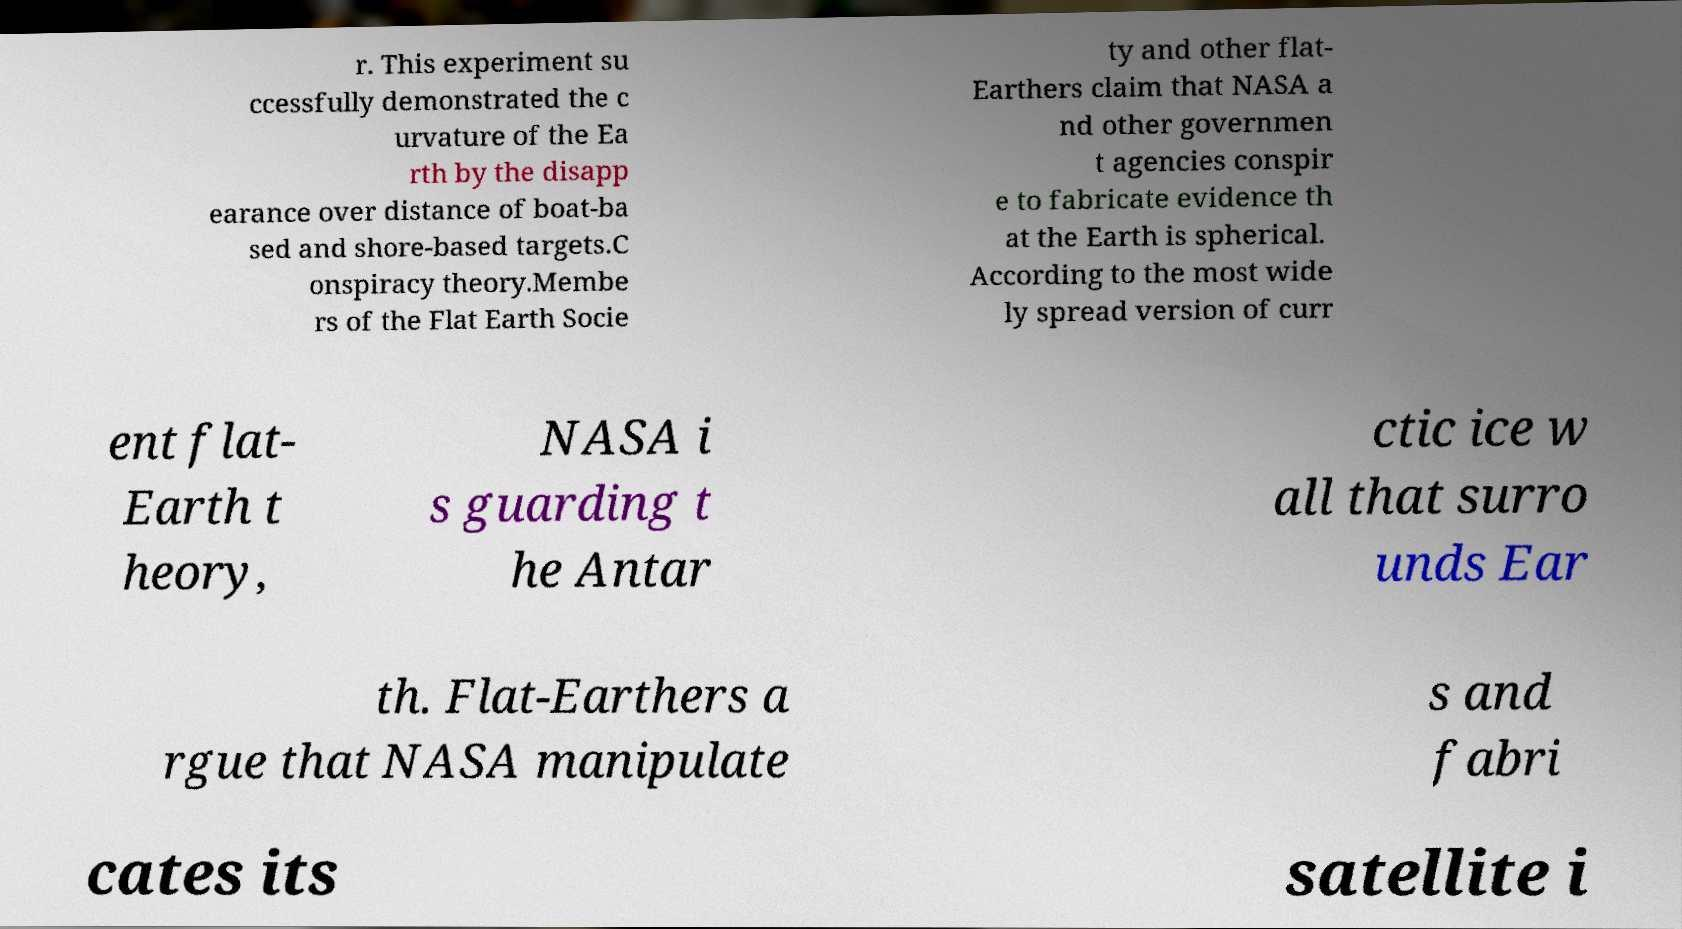Could you extract and type out the text from this image? r. This experiment su ccessfully demonstrated the c urvature of the Ea rth by the disapp earance over distance of boat-ba sed and shore-based targets.C onspiracy theory.Membe rs of the Flat Earth Socie ty and other flat- Earthers claim that NASA a nd other governmen t agencies conspir e to fabricate evidence th at the Earth is spherical. According to the most wide ly spread version of curr ent flat- Earth t heory, NASA i s guarding t he Antar ctic ice w all that surro unds Ear th. Flat-Earthers a rgue that NASA manipulate s and fabri cates its satellite i 